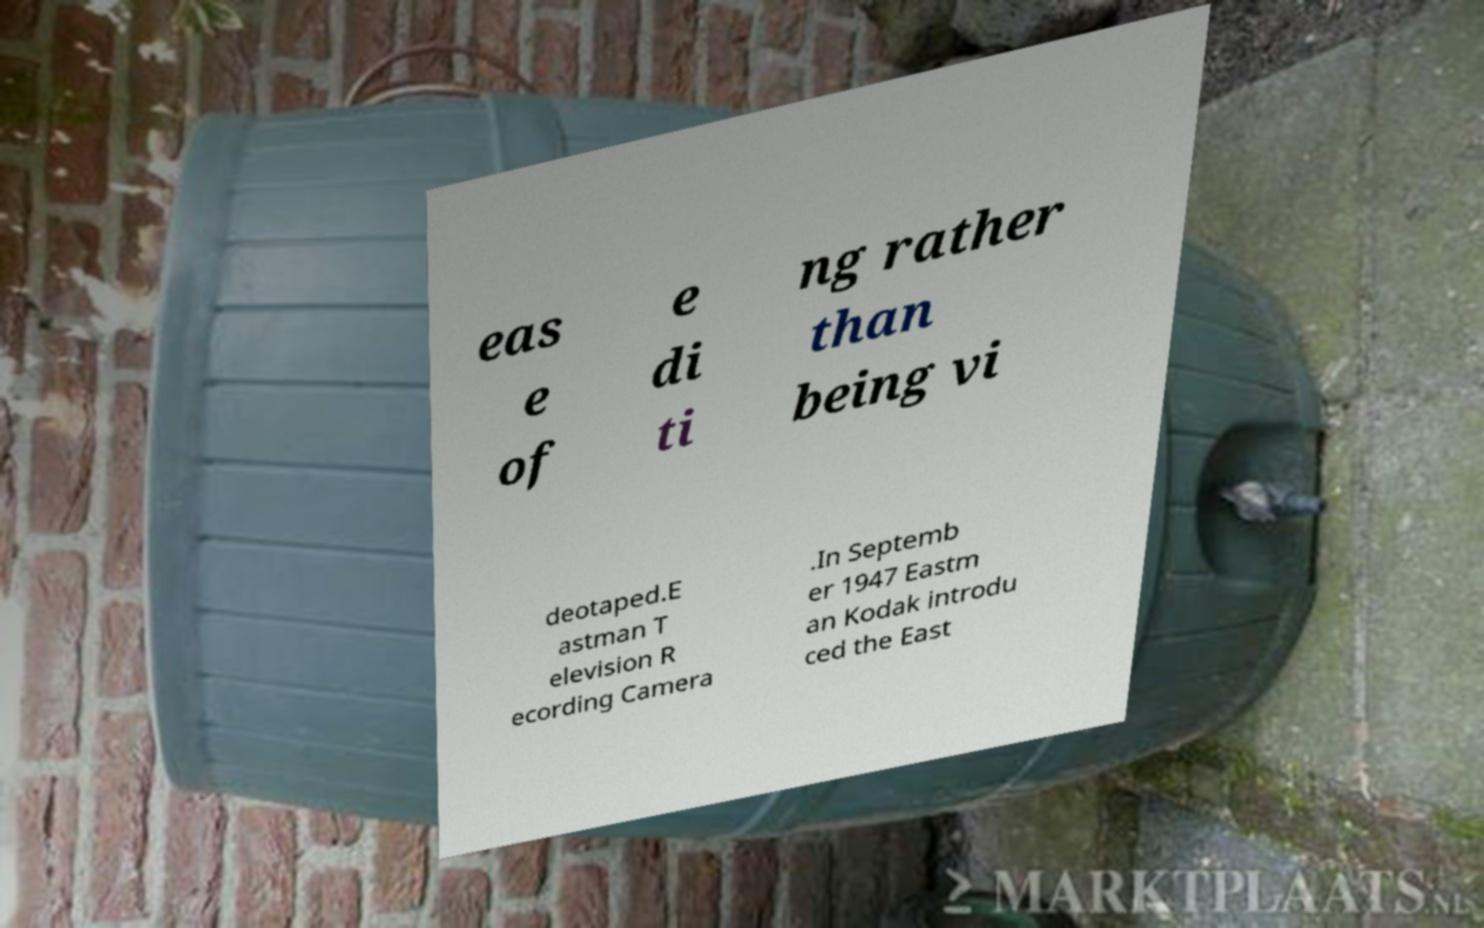Please read and relay the text visible in this image. What does it say? eas e of e di ti ng rather than being vi deotaped.E astman T elevision R ecording Camera .In Septemb er 1947 Eastm an Kodak introdu ced the East 